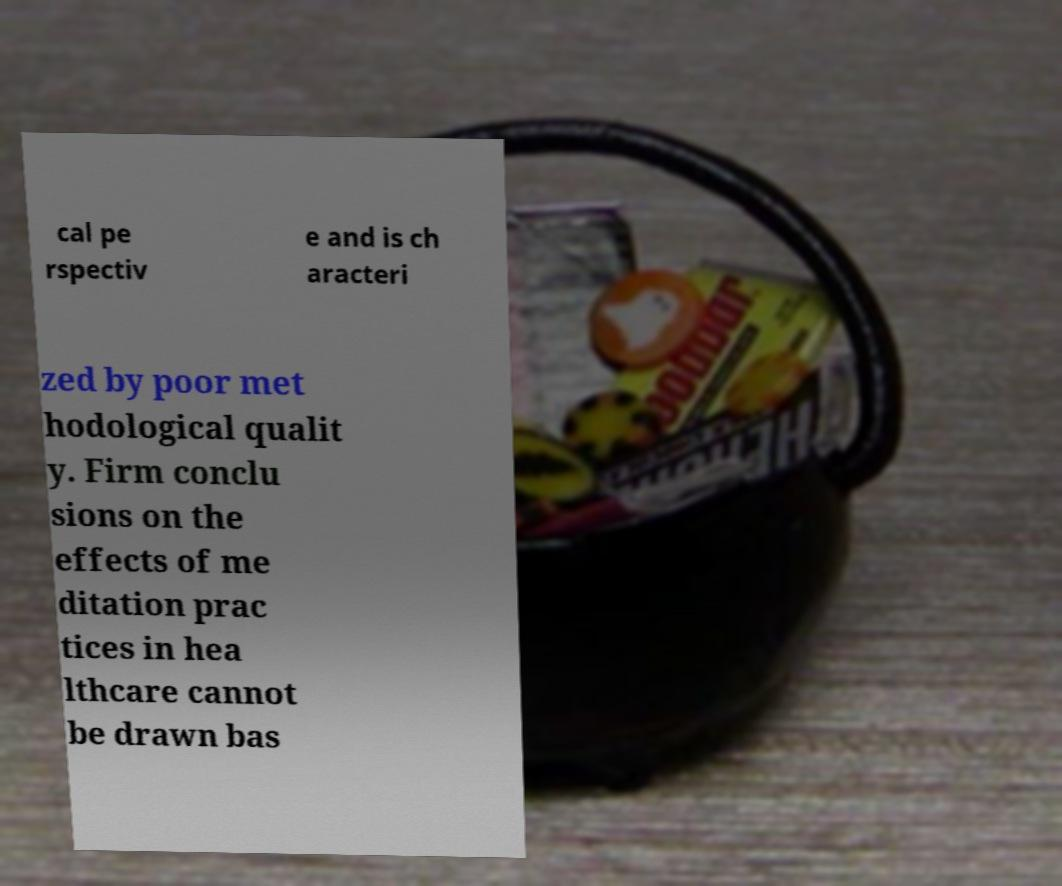Please read and relay the text visible in this image. What does it say? cal pe rspectiv e and is ch aracteri zed by poor met hodological qualit y. Firm conclu sions on the effects of me ditation prac tices in hea lthcare cannot be drawn bas 